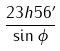<formula> <loc_0><loc_0><loc_500><loc_500>\frac { 2 3 h 5 6 ^ { \prime } } { \sin \phi }</formula> 